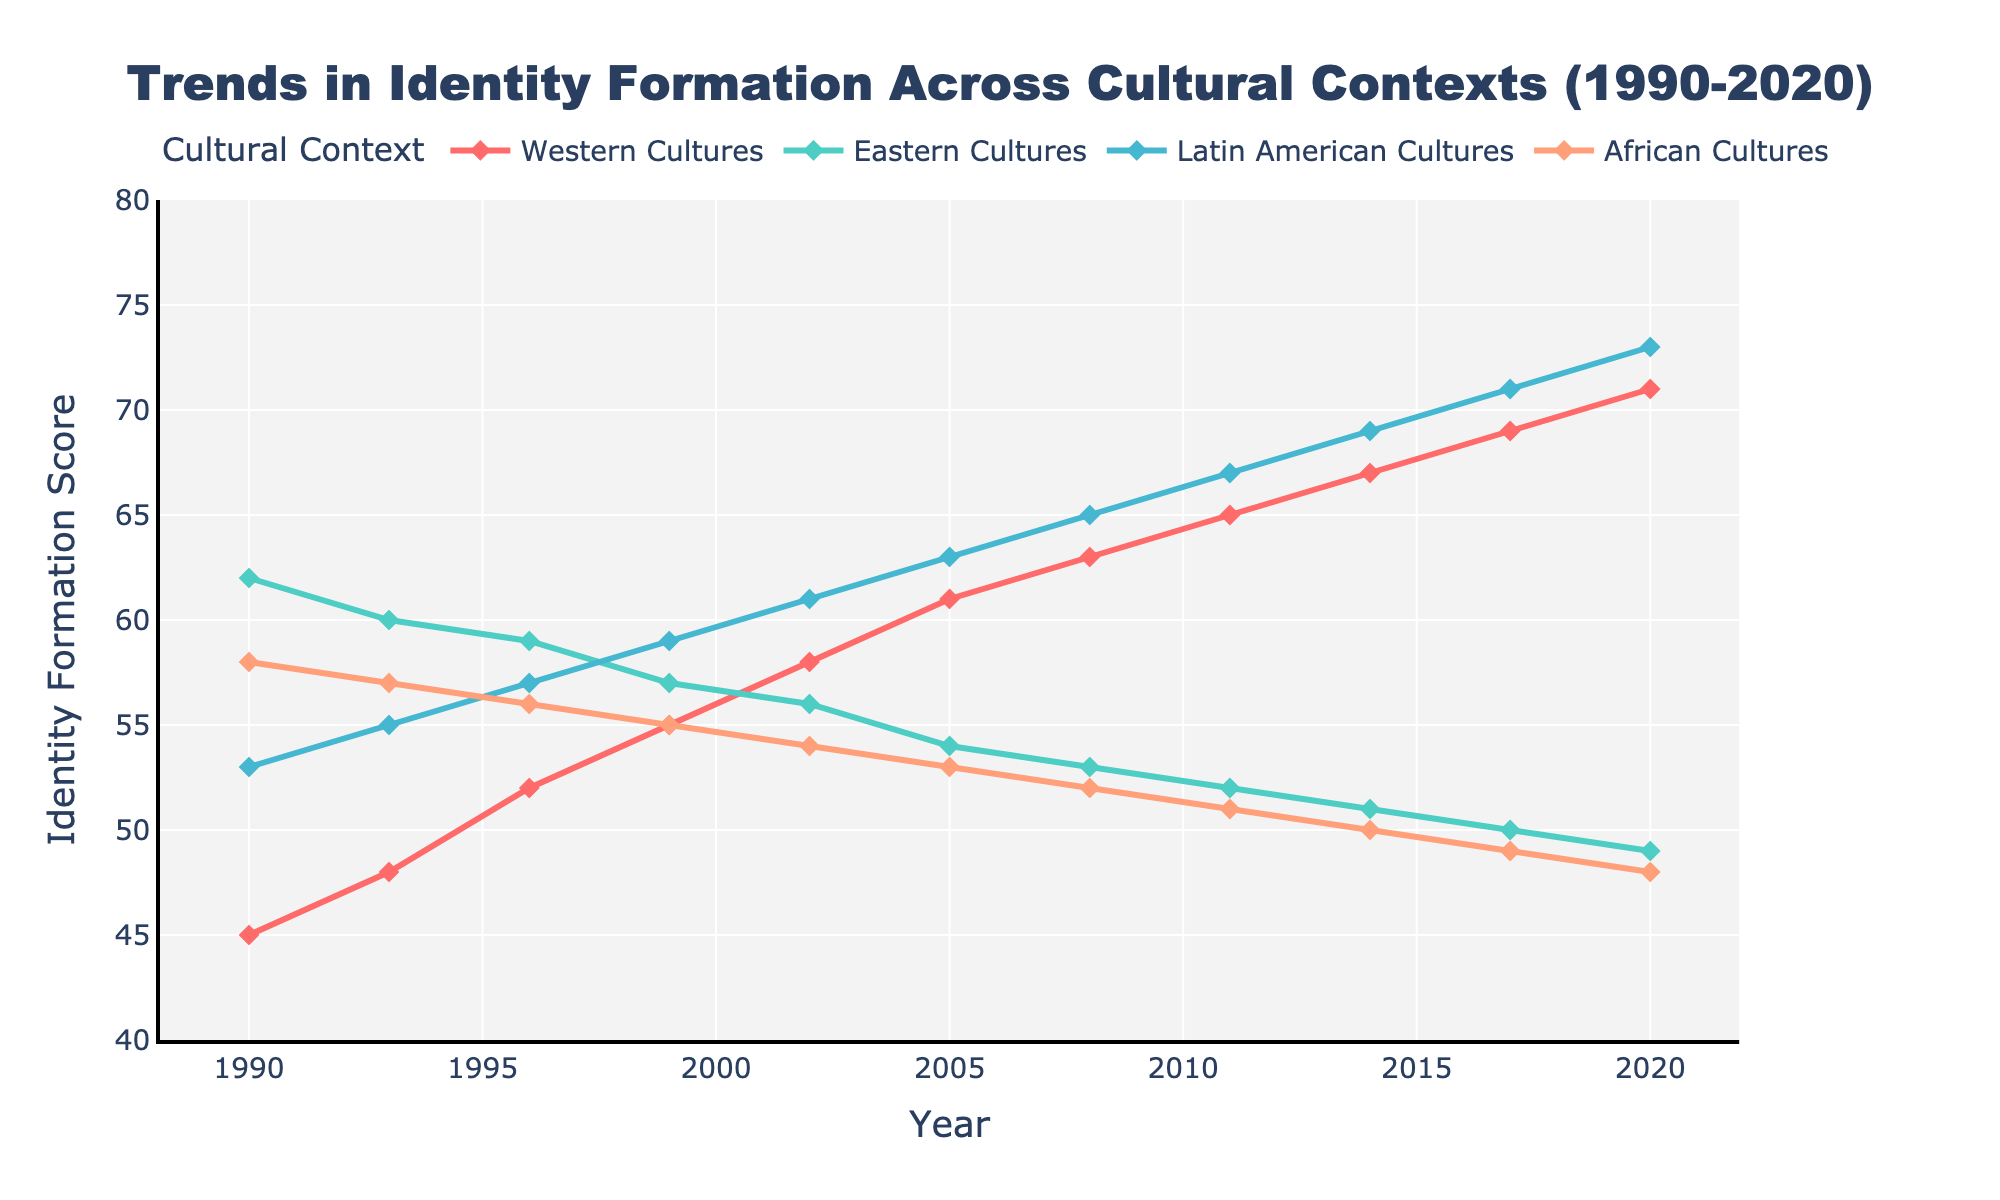What is the overall range of identity formation scores for Western Cultures between 1990 and 2020? The identity formation scores for Western Cultures range from 45 in 1990 to 71 in 2020. The range is calculated as the difference between the highest and lowest values (71 - 45).
Answer: 26 Which cultural context experienced the steepest increase in identity formation over the 30 years? To determine which cultural context experienced the steepest increase, look at the differences between the scores from 1990 and 2020 for each context. Western Cultures increased from 45 to 71 (26), Eastern Cultures decreased from 62 to 49 (-13), Latin American Cultures increased from 53 to 73 (20), and African Cultures decreased from 58 to 48 (-10). Western Cultures had the highest positive change.
Answer: Western Cultures By how much did the identity formation score in Latin American Cultures increase from 1990 to 2020? The identity formation score for Latin American Cultures was 53 in 1990 and 73 in 2020. The increase is calculated as the difference between these two values (73 - 53).
Answer: 20 Which cultural context(s) had a constant decline in identity formation scores over the studied period? Eastern Cultures started at 62 in 1990 and ended at 49 in 2020, with a consistent decrease over the years. Similarly, African Cultures saw a decline from 58 in 1990 to 48 in 2020. Therefore, both Eastern and African Cultures had a constant decline.
Answer: Eastern Cultures, African Cultures What is the average identity formation score for African Cultures over the given time period? The scores for African Cultures from 1990 to 2020 are 58, 57, 56, 55, 54, 53, 52, 51, 50, 49, and 48. The average is calculated by summing these values and dividing by 11 (years): (58 + 57 + 56 + 55 + 54 + 53 + 52 + 51 + 50 + 49 + 48) / 11. The total is 583, and dividing this by 11 gives approximately 53.
Answer: 53 During which years did Western Cultures surpass Eastern Cultures in identity formation scores? To determine when Western Cultures surpassed Eastern Cultures, compare the scores year by year. Western Cultures surpassed Eastern Cultures starting in 1996 (52 vs. 59) and continued to have higher scores in subsequent years (55>57, 58>56, 61>54, 63>53, 65>52, 67>51, 69>50, 71>49).
Answer: 1996 Which cultural context had the smallest rate of change in identity formation scores between 1990 and 2020? The rate of change can be determined by examining the total change over 30 years for each context: Western (26 increase), Eastern (-13 decrease), Latin American (20 increase), and African (-10 decrease). The smallest rate of change is seen in African Cultures, which decreased by only 10 points.
Answer: African Cultures What is the combined identity formation score for all cultural contexts in the year 2011? The identity formation scores in 2011 are: Western Cultures (65), Eastern Cultures (52), Latin American Cultures (67), and African Cultures (51). Summing these values gives: 65 + 52 + 67 + 51. The combined score is 235.
Answer: 235 Which cultural context had the highest variance in identity formation scores over the given period? To determine the variance, we need to look at the range and distribution of scores. Western Cultures had a significant increase from 45 to 71 (range 26), Eastern Cultures had a decrease from 62 to 49 (range 13), Latin American Cultures increased from 53 to 73 (range 20), and African Cultures decreased from 58 to 48 (range 10). Western Cultures had the largest change, indicating the highest variance.
Answer: Western Cultures 